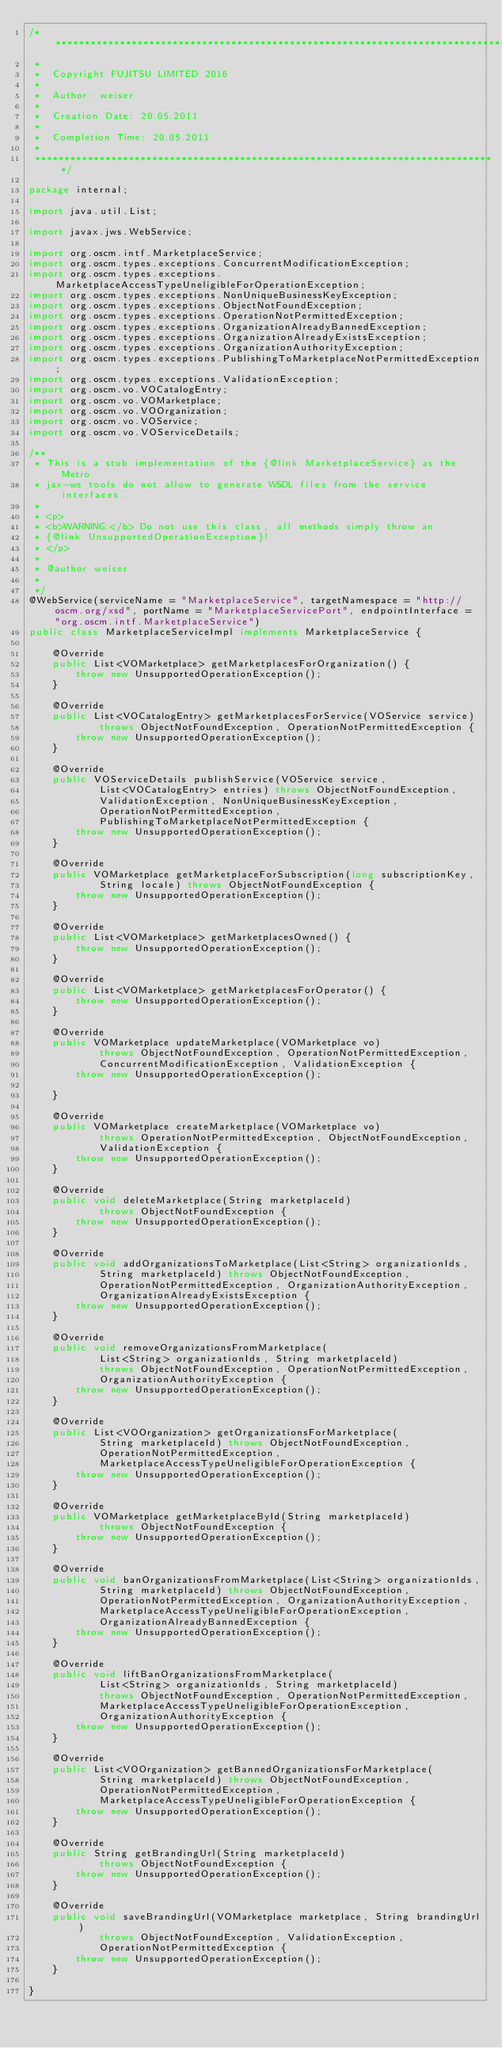<code> <loc_0><loc_0><loc_500><loc_500><_Java_>/*******************************************************************************
 *                                                                              
 *  Copyright FUJITSU LIMITED 2016                                             
 *                                                                              
 *  Author: weiser                                                      
 *                                                                              
 *  Creation Date: 20.05.2011                                                      
 *                                                                              
 *  Completion Time: 20.05.2011                                              
 *                                                                              
 *******************************************************************************/

package internal;

import java.util.List;

import javax.jws.WebService;

import org.oscm.intf.MarketplaceService;
import org.oscm.types.exceptions.ConcurrentModificationException;
import org.oscm.types.exceptions.MarketplaceAccessTypeUneligibleForOperationException;
import org.oscm.types.exceptions.NonUniqueBusinessKeyException;
import org.oscm.types.exceptions.ObjectNotFoundException;
import org.oscm.types.exceptions.OperationNotPermittedException;
import org.oscm.types.exceptions.OrganizationAlreadyBannedException;
import org.oscm.types.exceptions.OrganizationAlreadyExistsException;
import org.oscm.types.exceptions.OrganizationAuthorityException;
import org.oscm.types.exceptions.PublishingToMarketplaceNotPermittedException;
import org.oscm.types.exceptions.ValidationException;
import org.oscm.vo.VOCatalogEntry;
import org.oscm.vo.VOMarketplace;
import org.oscm.vo.VOOrganization;
import org.oscm.vo.VOService;
import org.oscm.vo.VOServiceDetails;

/**
 * This is a stub implementation of the {@link MarketplaceService} as the Metro
 * jax-ws tools do not allow to generate WSDL files from the service interfaces.
 * 
 * <p>
 * <b>WARNING:</b> Do not use this class, all methods simply throw an
 * {@link UnsupportedOperationException}!
 * </p>
 * 
 * @author weiser
 * 
 */
@WebService(serviceName = "MarketplaceService", targetNamespace = "http://oscm.org/xsd", portName = "MarketplaceServicePort", endpointInterface = "org.oscm.intf.MarketplaceService")
public class MarketplaceServiceImpl implements MarketplaceService {

    @Override
    public List<VOMarketplace> getMarketplacesForOrganization() {
        throw new UnsupportedOperationException();
    }

    @Override
    public List<VOCatalogEntry> getMarketplacesForService(VOService service)
            throws ObjectNotFoundException, OperationNotPermittedException {
        throw new UnsupportedOperationException();
    }

    @Override
    public VOServiceDetails publishService(VOService service,
            List<VOCatalogEntry> entries) throws ObjectNotFoundException,
            ValidationException, NonUniqueBusinessKeyException,
            OperationNotPermittedException,
            PublishingToMarketplaceNotPermittedException {
        throw new UnsupportedOperationException();
    }

    @Override
    public VOMarketplace getMarketplaceForSubscription(long subscriptionKey,
            String locale) throws ObjectNotFoundException {
        throw new UnsupportedOperationException();
    }

    @Override
    public List<VOMarketplace> getMarketplacesOwned() {
        throw new UnsupportedOperationException();
    }

    @Override
    public List<VOMarketplace> getMarketplacesForOperator() {
        throw new UnsupportedOperationException();
    }

    @Override
    public VOMarketplace updateMarketplace(VOMarketplace vo)
            throws ObjectNotFoundException, OperationNotPermittedException,
            ConcurrentModificationException, ValidationException {
        throw new UnsupportedOperationException();

    }

    @Override
    public VOMarketplace createMarketplace(VOMarketplace vo)
            throws OperationNotPermittedException, ObjectNotFoundException,
            ValidationException {
        throw new UnsupportedOperationException();
    }

    @Override
    public void deleteMarketplace(String marketplaceId)
            throws ObjectNotFoundException {
        throw new UnsupportedOperationException();
    }

    @Override
    public void addOrganizationsToMarketplace(List<String> organizationIds,
            String marketplaceId) throws ObjectNotFoundException,
            OperationNotPermittedException, OrganizationAuthorityException,
            OrganizationAlreadyExistsException {
        throw new UnsupportedOperationException();
    }

    @Override
    public void removeOrganizationsFromMarketplace(
            List<String> organizationIds, String marketplaceId)
            throws ObjectNotFoundException, OperationNotPermittedException,
            OrganizationAuthorityException {
        throw new UnsupportedOperationException();
    }

    @Override
    public List<VOOrganization> getOrganizationsForMarketplace(
            String marketplaceId) throws ObjectNotFoundException,
            OperationNotPermittedException,
            MarketplaceAccessTypeUneligibleForOperationException {
        throw new UnsupportedOperationException();
    }

    @Override
    public VOMarketplace getMarketplaceById(String marketplaceId)
            throws ObjectNotFoundException {
        throw new UnsupportedOperationException();
    }

    @Override
    public void banOrganizationsFromMarketplace(List<String> organizationIds,
            String marketplaceId) throws ObjectNotFoundException,
            OperationNotPermittedException, OrganizationAuthorityException,
            MarketplaceAccessTypeUneligibleForOperationException,
            OrganizationAlreadyBannedException {
        throw new UnsupportedOperationException();
    }

    @Override
    public void liftBanOrganizationsFromMarketplace(
            List<String> organizationIds, String marketplaceId)
            throws ObjectNotFoundException, OperationNotPermittedException,
            MarketplaceAccessTypeUneligibleForOperationException,
            OrganizationAuthorityException {
        throw new UnsupportedOperationException();
    }

    @Override
    public List<VOOrganization> getBannedOrganizationsForMarketplace(
            String marketplaceId) throws ObjectNotFoundException,
            OperationNotPermittedException,
            MarketplaceAccessTypeUneligibleForOperationException {
        throw new UnsupportedOperationException();
    }

    @Override
    public String getBrandingUrl(String marketplaceId)
            throws ObjectNotFoundException {
        throw new UnsupportedOperationException();
    }

    @Override
    public void saveBrandingUrl(VOMarketplace marketplace, String brandingUrl)
            throws ObjectNotFoundException, ValidationException,
            OperationNotPermittedException {
        throw new UnsupportedOperationException();
    }

}
</code> 